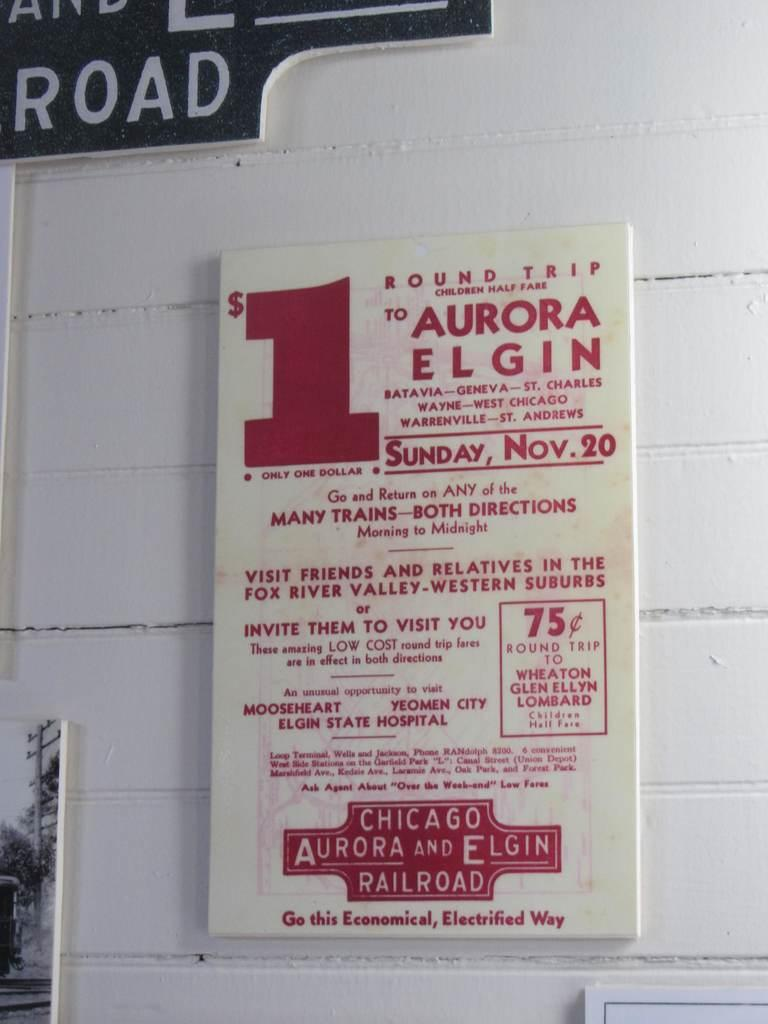Provide a one-sentence caption for the provided image. a paper ad stating $ 1 to aurora elgin. 